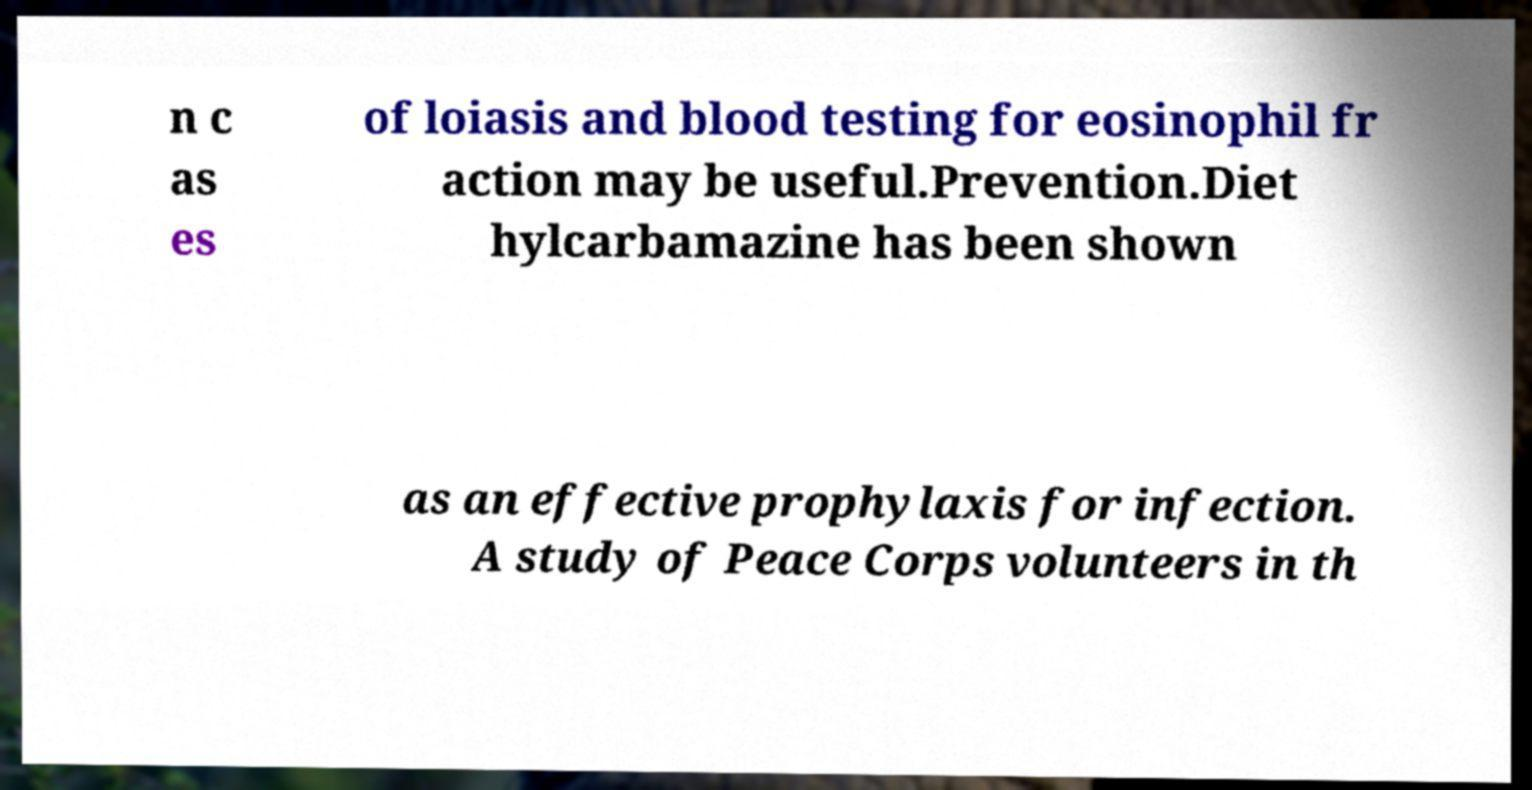Please read and relay the text visible in this image. What does it say? n c as es of loiasis and blood testing for eosinophil fr action may be useful.Prevention.Diet hylcarbamazine has been shown as an effective prophylaxis for infection. A study of Peace Corps volunteers in th 